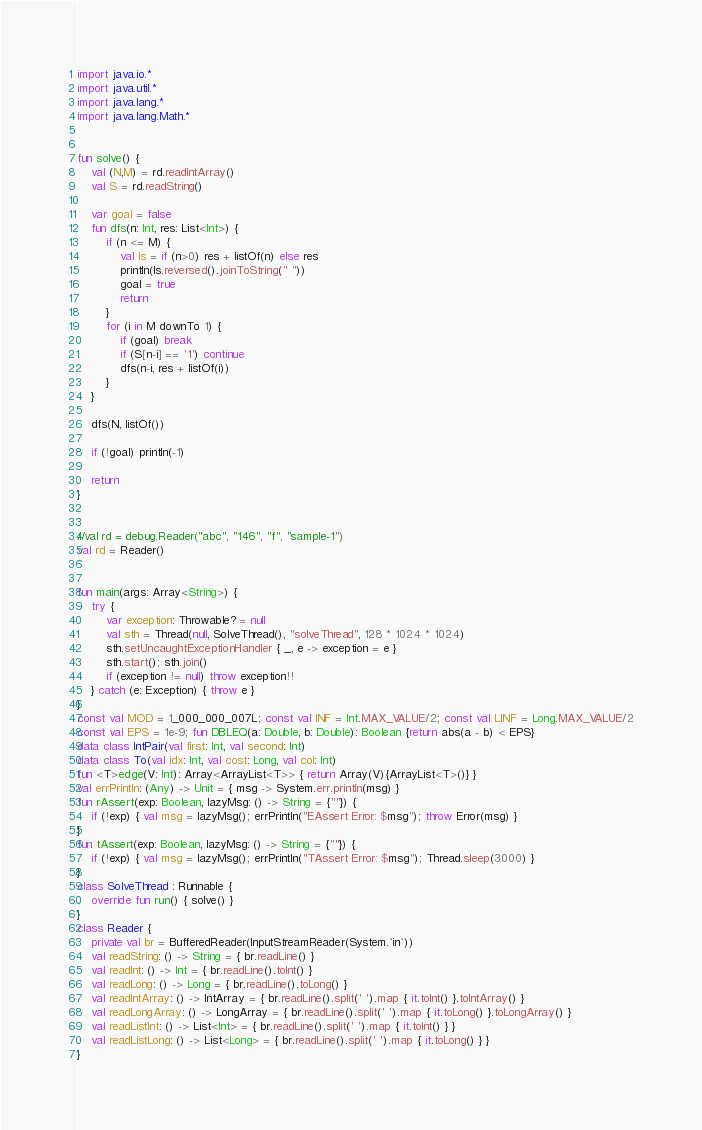Convert code to text. <code><loc_0><loc_0><loc_500><loc_500><_Kotlin_>import java.io.*
import java.util.*
import java.lang.*
import java.lang.Math.*


fun solve() {
    val (N,M) = rd.readIntArray()
    val S = rd.readString()

    var goal = false
    fun dfs(n: Int, res: List<Int>) {
        if (n <= M) {
            val ls = if (n>0) res + listOf(n) else res
            println(ls.reversed().joinToString(" "))
            goal = true
            return
        }
        for (i in M downTo 1) {
            if (goal) break
            if (S[n-i] == '1') continue
            dfs(n-i, res + listOf(i))
        }
    }

    dfs(N, listOf())

    if (!goal) println(-1)

    return
}


//val rd = debug.Reader("abc", "146", "f", "sample-1")
val rd = Reader()


fun main(args: Array<String>) {
    try {
        var exception: Throwable? = null
        val sth = Thread(null, SolveThread(), "solveThread", 128 * 1024 * 1024)
        sth.setUncaughtExceptionHandler { _, e -> exception = e }
        sth.start(); sth.join()
        if (exception != null) throw exception!!
    } catch (e: Exception) { throw e }
}
const val MOD = 1_000_000_007L; const val INF = Int.MAX_VALUE/2; const val LINF = Long.MAX_VALUE/2
const val EPS = 1e-9; fun DBLEQ(a: Double, b: Double): Boolean {return abs(a - b) < EPS}
data class IntPair(val first: Int, val second: Int)
data class To(val idx: Int, val cost: Long, val col: Int)
fun <T>edge(V: Int): Array<ArrayList<T>> { return Array(V){ArrayList<T>()} }
val errPrintln: (Any) -> Unit = { msg -> System.err.println(msg) }
fun rAssert(exp: Boolean, lazyMsg: () -> String = {""}) {
    if (!exp) { val msg = lazyMsg(); errPrintln("EAssert Error: $msg"); throw Error(msg) }
}
fun tAssert(exp: Boolean, lazyMsg: () -> String = {""}) {
    if (!exp) { val msg = lazyMsg(); errPrintln("TAssert Error: $msg"); Thread.sleep(3000) }
}
class SolveThread : Runnable {
    override fun run() { solve() }
}
class Reader {
    private val br = BufferedReader(InputStreamReader(System.`in`))
    val readString: () -> String = { br.readLine() }
    val readInt: () -> Int = { br.readLine().toInt() }
    val readLong: () -> Long = { br.readLine().toLong() }
    val readIntArray: () -> IntArray = { br.readLine().split(' ').map { it.toInt() }.toIntArray() }
    val readLongArray: () -> LongArray = { br.readLine().split(' ').map { it.toLong() }.toLongArray() }
    val readListInt: () -> List<Int> = { br.readLine().split(' ').map { it.toInt() } }
    val readListLong: () -> List<Long> = { br.readLine().split(' ').map { it.toLong() } }
}
</code> 